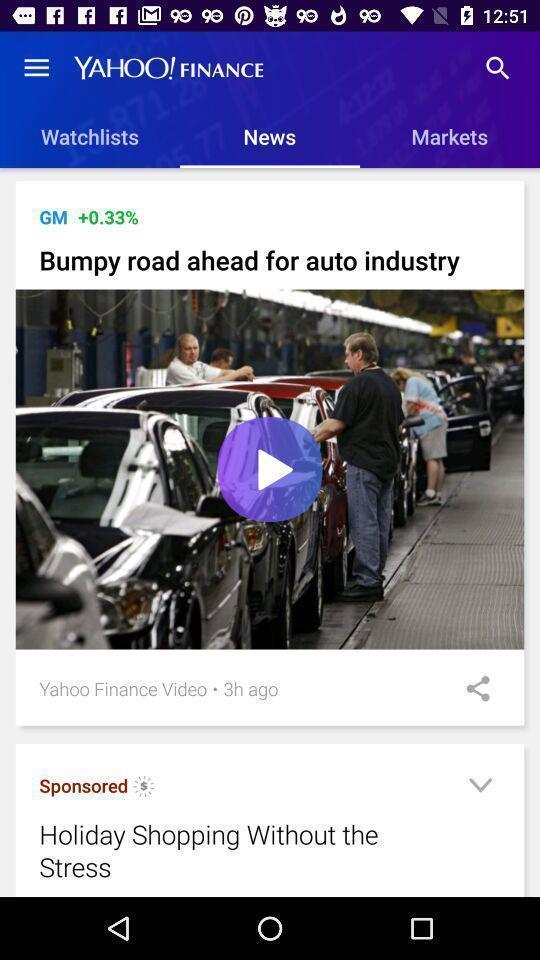Describe the content in this image. Screen displaying news. 